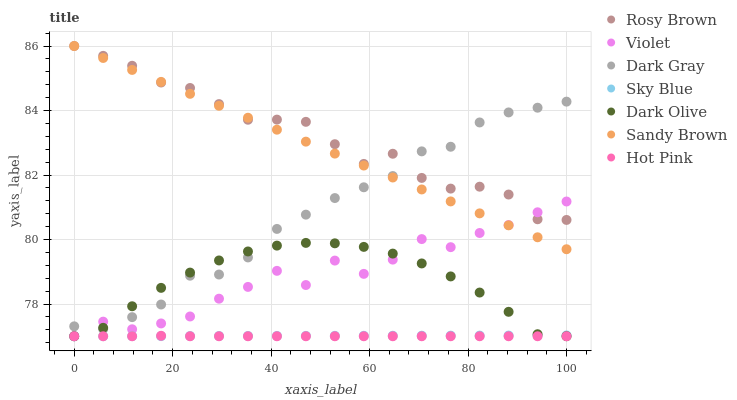Does Hot Pink have the minimum area under the curve?
Answer yes or no. Yes. Does Rosy Brown have the maximum area under the curve?
Answer yes or no. Yes. Does Dark Gray have the minimum area under the curve?
Answer yes or no. No. Does Dark Gray have the maximum area under the curve?
Answer yes or no. No. Is Sandy Brown the smoothest?
Answer yes or no. Yes. Is Violet the roughest?
Answer yes or no. Yes. Is Rosy Brown the smoothest?
Answer yes or no. No. Is Rosy Brown the roughest?
Answer yes or no. No. Does Dark Olive have the lowest value?
Answer yes or no. Yes. Does Dark Gray have the lowest value?
Answer yes or no. No. Does Sandy Brown have the highest value?
Answer yes or no. Yes. Does Dark Gray have the highest value?
Answer yes or no. No. Is Hot Pink less than Rosy Brown?
Answer yes or no. Yes. Is Dark Gray greater than Sky Blue?
Answer yes or no. Yes. Does Dark Gray intersect Dark Olive?
Answer yes or no. Yes. Is Dark Gray less than Dark Olive?
Answer yes or no. No. Is Dark Gray greater than Dark Olive?
Answer yes or no. No. Does Hot Pink intersect Rosy Brown?
Answer yes or no. No. 